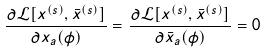<formula> <loc_0><loc_0><loc_500><loc_500>\frac { \partial \mathcal { L } [ x ^ { ( s ) } , \bar { x } ^ { ( s ) } ] } { \partial x _ { a } ( \phi ) } = \frac { \partial \mathcal { L } [ x ^ { ( s ) } , \bar { x } ^ { ( s ) } ] } { \partial \bar { x } _ { a } ( \phi ) } = 0</formula> 